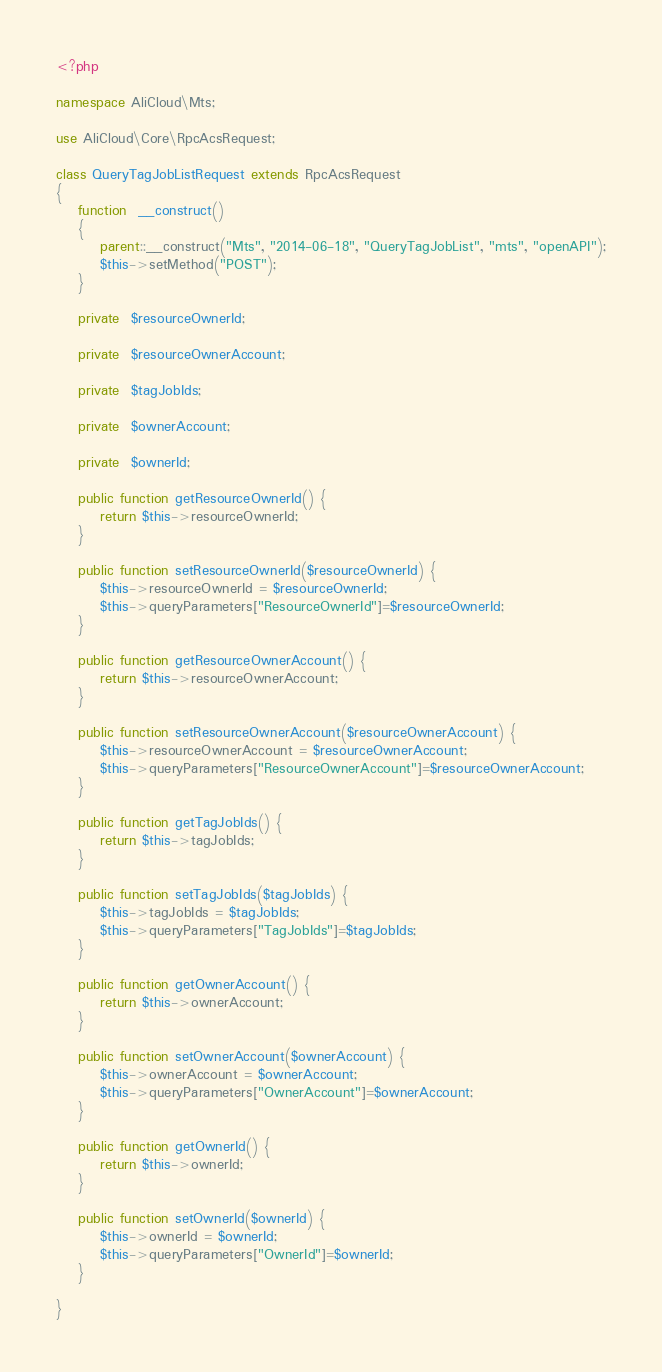Convert code to text. <code><loc_0><loc_0><loc_500><loc_500><_PHP_><?php

namespace AliCloud\Mts;

use AliCloud\Core\RpcAcsRequest;

class QueryTagJobListRequest extends RpcAcsRequest
{
	function  __construct()
	{
		parent::__construct("Mts", "2014-06-18", "QueryTagJobList", "mts", "openAPI");
		$this->setMethod("POST");
	}

	private  $resourceOwnerId;

	private  $resourceOwnerAccount;

	private  $tagJobIds;

	private  $ownerAccount;

	private  $ownerId;

	public function getResourceOwnerId() {
		return $this->resourceOwnerId;
	}

	public function setResourceOwnerId($resourceOwnerId) {
		$this->resourceOwnerId = $resourceOwnerId;
		$this->queryParameters["ResourceOwnerId"]=$resourceOwnerId;
	}

	public function getResourceOwnerAccount() {
		return $this->resourceOwnerAccount;
	}

	public function setResourceOwnerAccount($resourceOwnerAccount) {
		$this->resourceOwnerAccount = $resourceOwnerAccount;
		$this->queryParameters["ResourceOwnerAccount"]=$resourceOwnerAccount;
	}

	public function getTagJobIds() {
		return $this->tagJobIds;
	}

	public function setTagJobIds($tagJobIds) {
		$this->tagJobIds = $tagJobIds;
		$this->queryParameters["TagJobIds"]=$tagJobIds;
	}

	public function getOwnerAccount() {
		return $this->ownerAccount;
	}

	public function setOwnerAccount($ownerAccount) {
		$this->ownerAccount = $ownerAccount;
		$this->queryParameters["OwnerAccount"]=$ownerAccount;
	}

	public function getOwnerId() {
		return $this->ownerId;
	}

	public function setOwnerId($ownerId) {
		$this->ownerId = $ownerId;
		$this->queryParameters["OwnerId"]=$ownerId;
	}
	
}</code> 